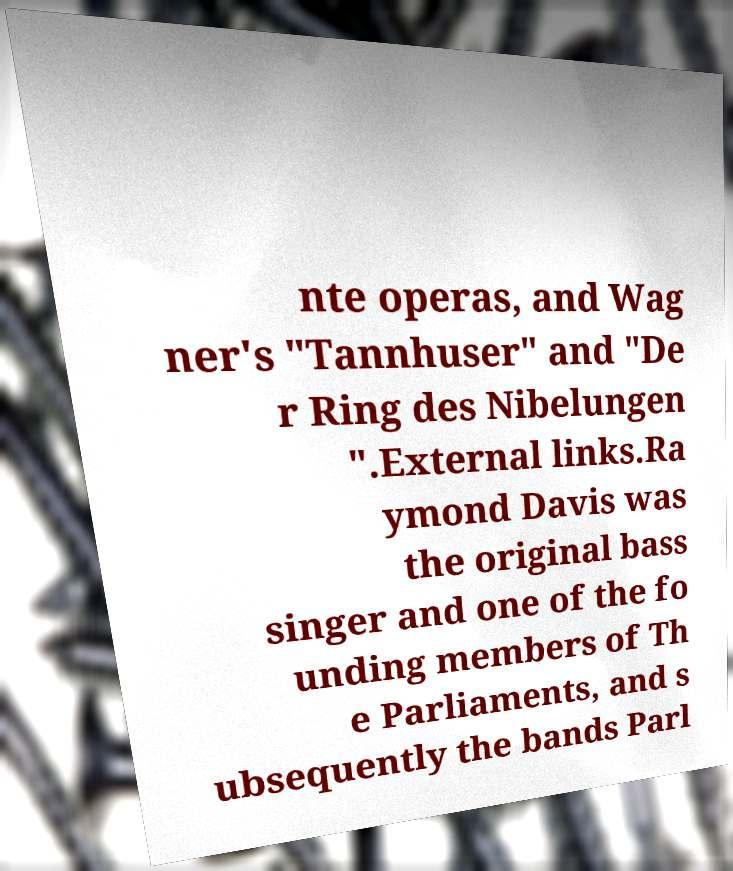Please identify and transcribe the text found in this image. nte operas, and Wag ner's "Tannhuser" and "De r Ring des Nibelungen ".External links.Ra ymond Davis was the original bass singer and one of the fo unding members of Th e Parliaments, and s ubsequently the bands Parl 